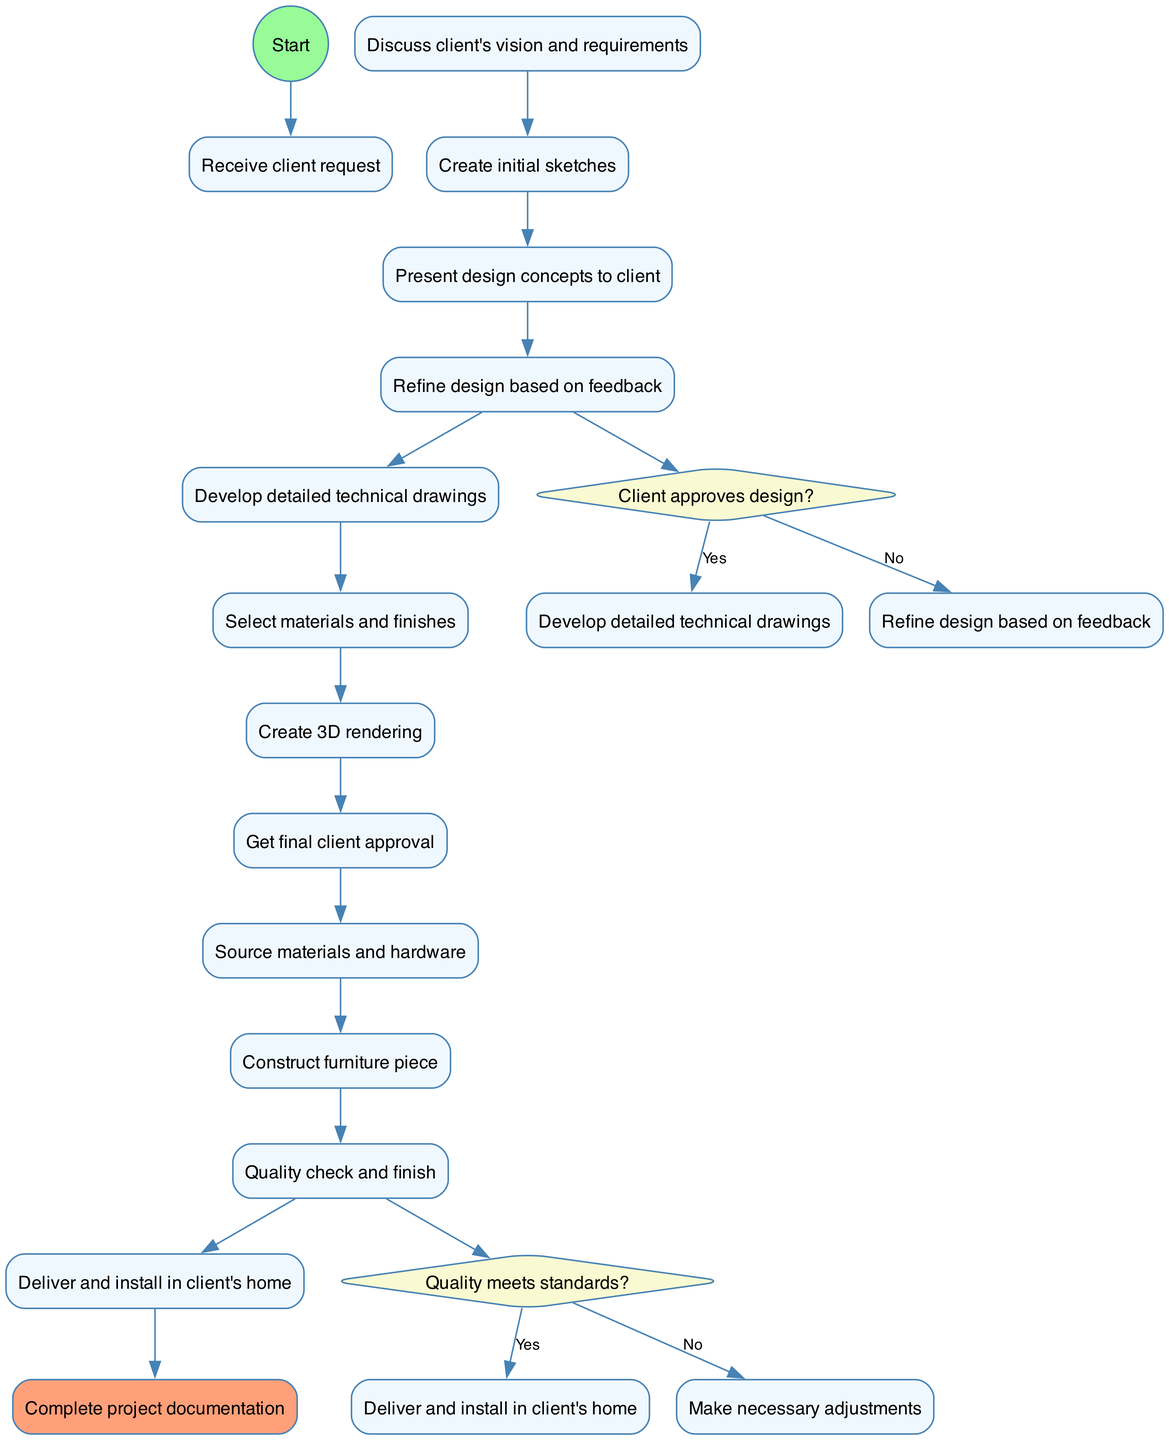What is the initial node in the workflow? The first node labeled in the diagram is "Receive client request," indicating the starting point of the workflow.
Answer: Receive client request How many activities are there in the diagram? The diagram lists a total of 12 activities, as enumerated in the activities section of the data.
Answer: 12 What question is posed at the first decision node? The first decision node presents the question "Client approves design?" which determines the next step in the process.
Answer: Client approves design? What is the next step if the client approves the design? If the design is approved by the client, the workflow proceeds to "Develop detailed technical drawings," escalating the design process to a more detailed level.
Answer: Develop detailed technical drawings What happens if quality does not meet standards? If quality checks reveal that the standards are not met, the workflow indicates that "Make necessary adjustments" should occur before proceeding to the next step.
Answer: Make necessary adjustments Describe the relationship between "Create initial sketches" and "Get final client approval." "Create initial sketches" is an earlier activity that leads to "Present design concepts to client," which eventually flows through "Refine design based on feedback" and culminates in "Get final client approval." Hence, they are connected sequentially in terms of workflow.
Answer: Sequential connection What is the final node indicated in the diagram? The final node in the workflow is "Complete project documentation," which signifies the end of the entire process after the delivery and installation of the furniture piece.
Answer: Complete project documentation How does the flow proceed after "Construct furniture piece"? After the "Construct furniture piece" activity, the flow leads directly to the decision node related to quality, where a check is performed to ensure the quality meets standards.
Answer: Decision on quality check What represents the decision node's "yes" outcome for the quality check? The "yes" outcome for the quality check directs the flow to "Deliver and install in client's home," which is the subsequent step if the quality is satisfactory.
Answer: Deliver and install in client's home 